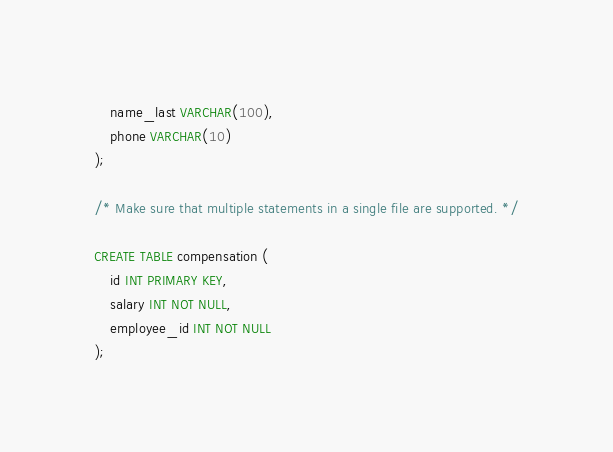<code> <loc_0><loc_0><loc_500><loc_500><_SQL_>    name_last VARCHAR(100),
    phone VARCHAR(10)
);

/* Make sure that multiple statements in a single file are supported. */

CREATE TABLE compensation (
    id INT PRIMARY KEY,
    salary INT NOT NULL,
    employee_id INT NOT NULL
);
</code> 